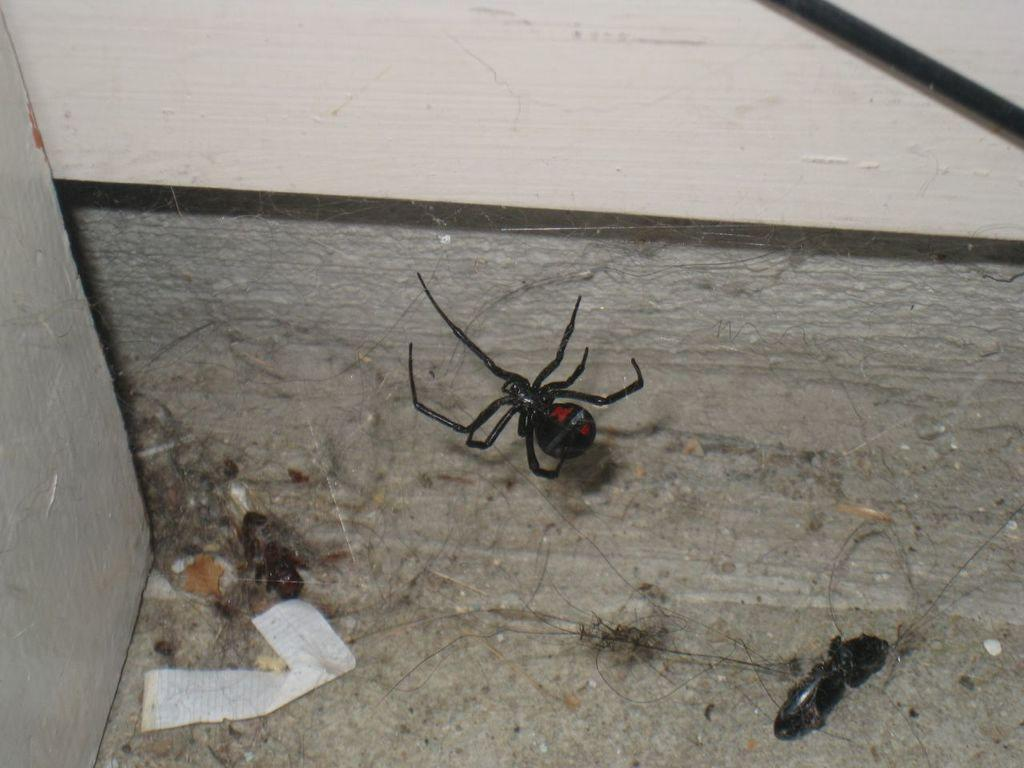What is the main subject of the image? There is a spider in the image. What is the spider doing in the image? The spider is standing on its web. What other living creature can be seen in the image? There is an insect in the image. Where is the insect located in the image? The insect is at the bottom of the image. What can be found in the corner of the room in the image? There are hairs and papers in the corner of the room in the image. Can you tell me who won the argument between the spider and the insect in the image? There is no argument between the spider and the insect in the image, as they are simply living creatures in their respective locations. 